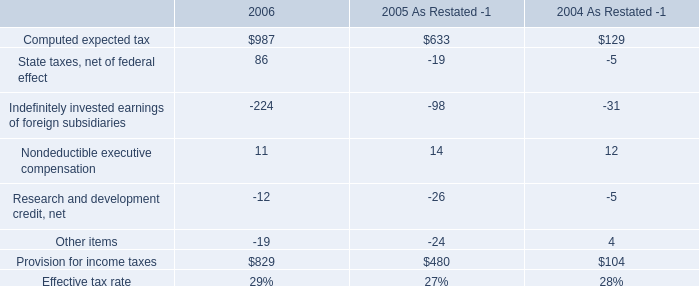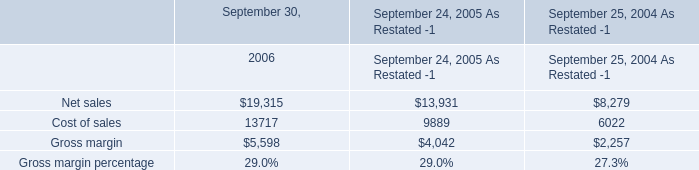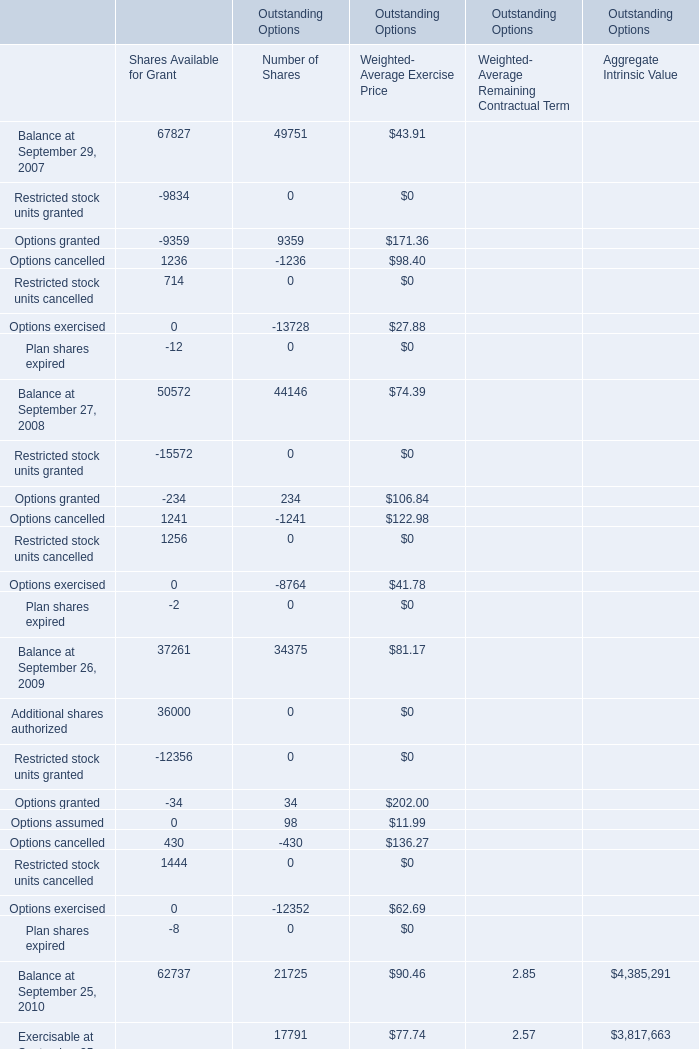what's the total amount of Options exercised of Outstanding Options Number of Shares, Net sales of September 30, 2006, and Options exercised of Outstanding Options Number of Shares ? 
Computations: ((12352.0 + 19315.0) + 8764.0)
Answer: 40431.0. What's the total amount of the Restricted stock units cancelled in the years where Restricted stock units cancelled is greater than 0? 
Computations: (714 + 1256)
Answer: 1970.0. 